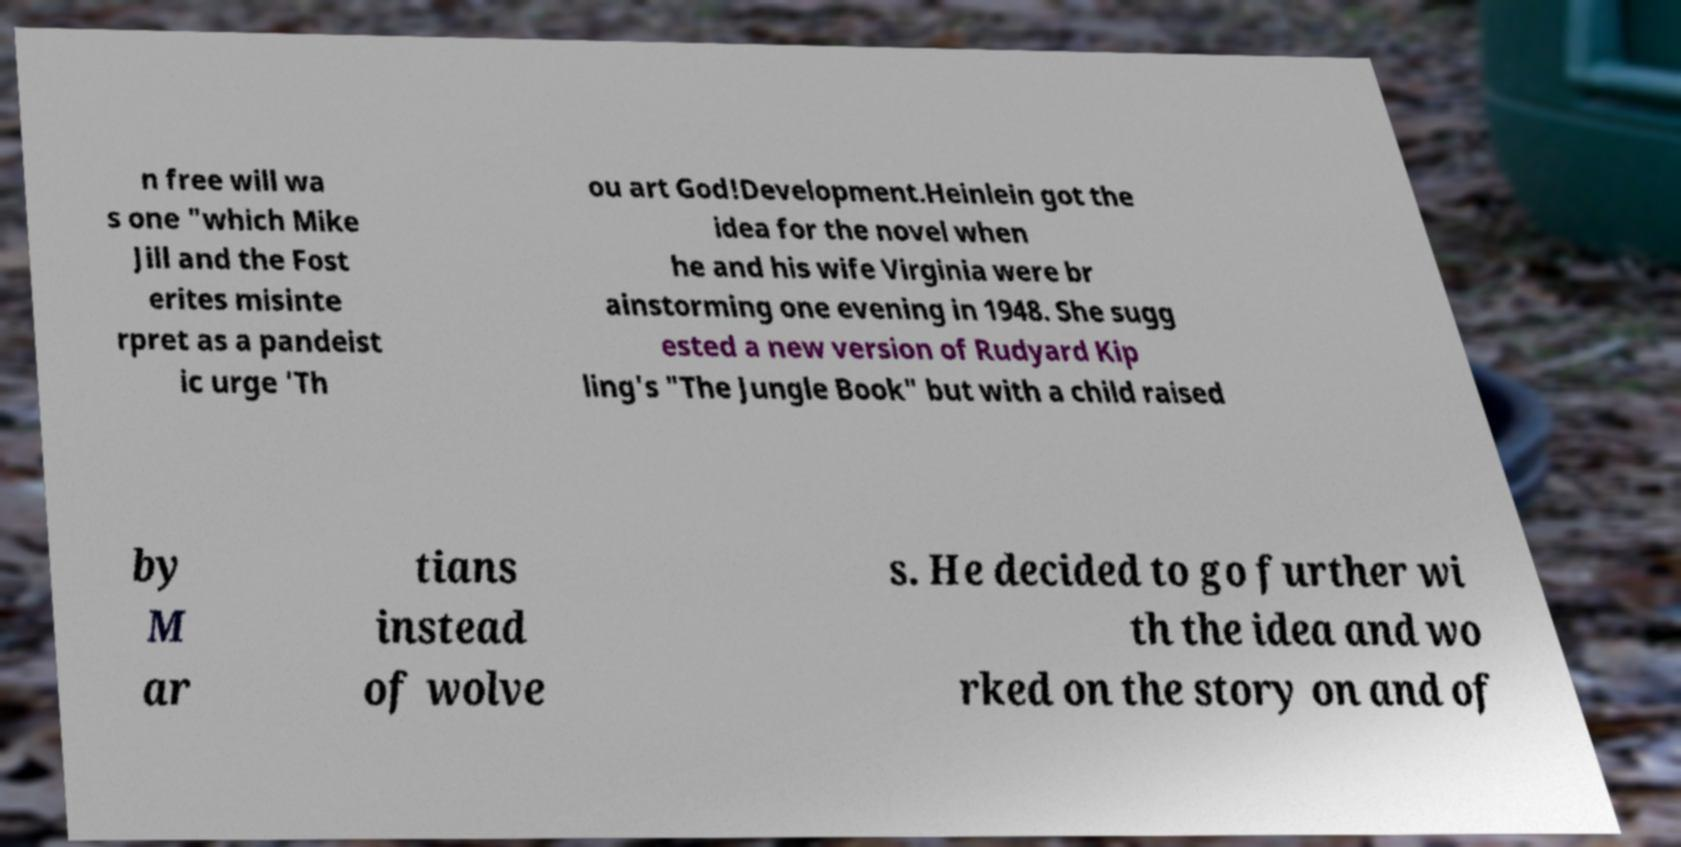Please read and relay the text visible in this image. What does it say? n free will wa s one "which Mike Jill and the Fost erites misinte rpret as a pandeist ic urge 'Th ou art God!Development.Heinlein got the idea for the novel when he and his wife Virginia were br ainstorming one evening in 1948. She sugg ested a new version of Rudyard Kip ling's "The Jungle Book" but with a child raised by M ar tians instead of wolve s. He decided to go further wi th the idea and wo rked on the story on and of 